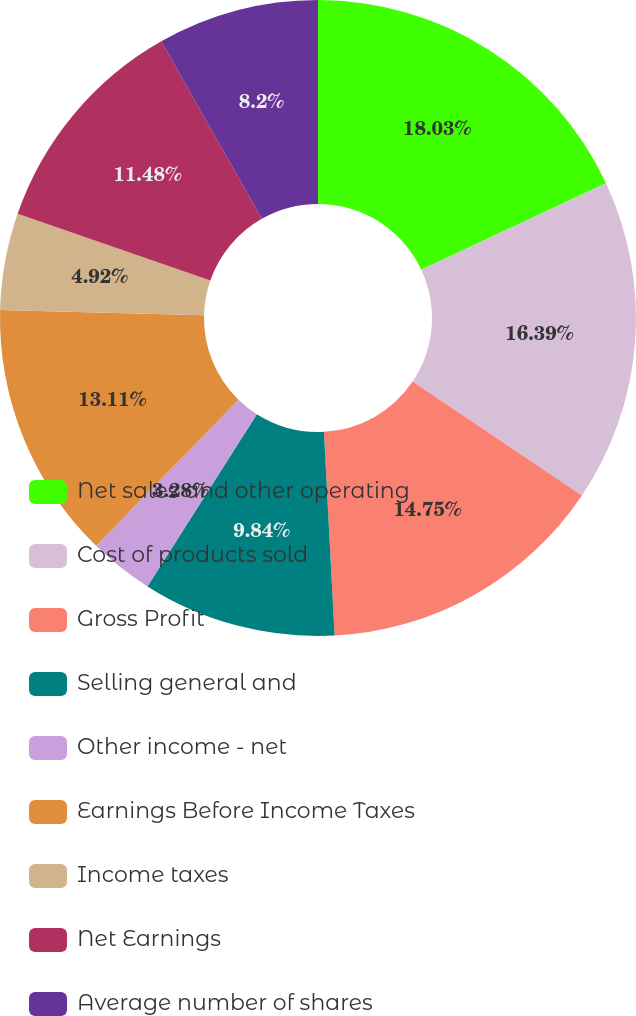<chart> <loc_0><loc_0><loc_500><loc_500><pie_chart><fcel>Net sales and other operating<fcel>Cost of products sold<fcel>Gross Profit<fcel>Selling general and<fcel>Other income - net<fcel>Earnings Before Income Taxes<fcel>Income taxes<fcel>Net Earnings<fcel>Average number of shares<nl><fcel>18.03%<fcel>16.39%<fcel>14.75%<fcel>9.84%<fcel>3.28%<fcel>13.11%<fcel>4.92%<fcel>11.48%<fcel>8.2%<nl></chart> 